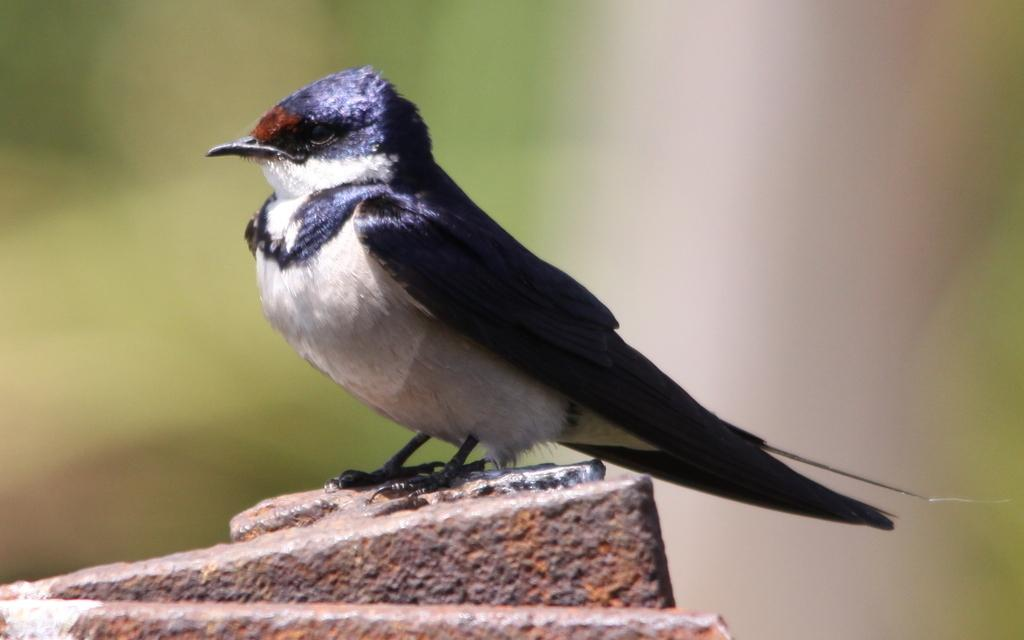What type of animal can be seen in the picture? There is a bird in the picture. Where is the bird located in the image? The bird is on a rock. What type of home does the bird live in within the picture? There is no information about the bird's home in the picture. 